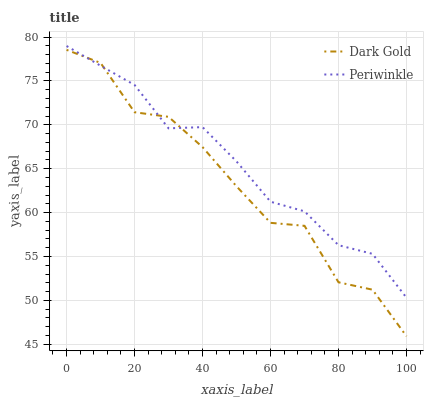Does Dark Gold have the minimum area under the curve?
Answer yes or no. Yes. Does Periwinkle have the maximum area under the curve?
Answer yes or no. Yes. Does Dark Gold have the maximum area under the curve?
Answer yes or no. No. Is Periwinkle the smoothest?
Answer yes or no. Yes. Is Dark Gold the roughest?
Answer yes or no. Yes. Is Dark Gold the smoothest?
Answer yes or no. No. Does Dark Gold have the lowest value?
Answer yes or no. Yes. Does Periwinkle have the highest value?
Answer yes or no. Yes. Does Dark Gold have the highest value?
Answer yes or no. No. Does Periwinkle intersect Dark Gold?
Answer yes or no. Yes. Is Periwinkle less than Dark Gold?
Answer yes or no. No. Is Periwinkle greater than Dark Gold?
Answer yes or no. No. 